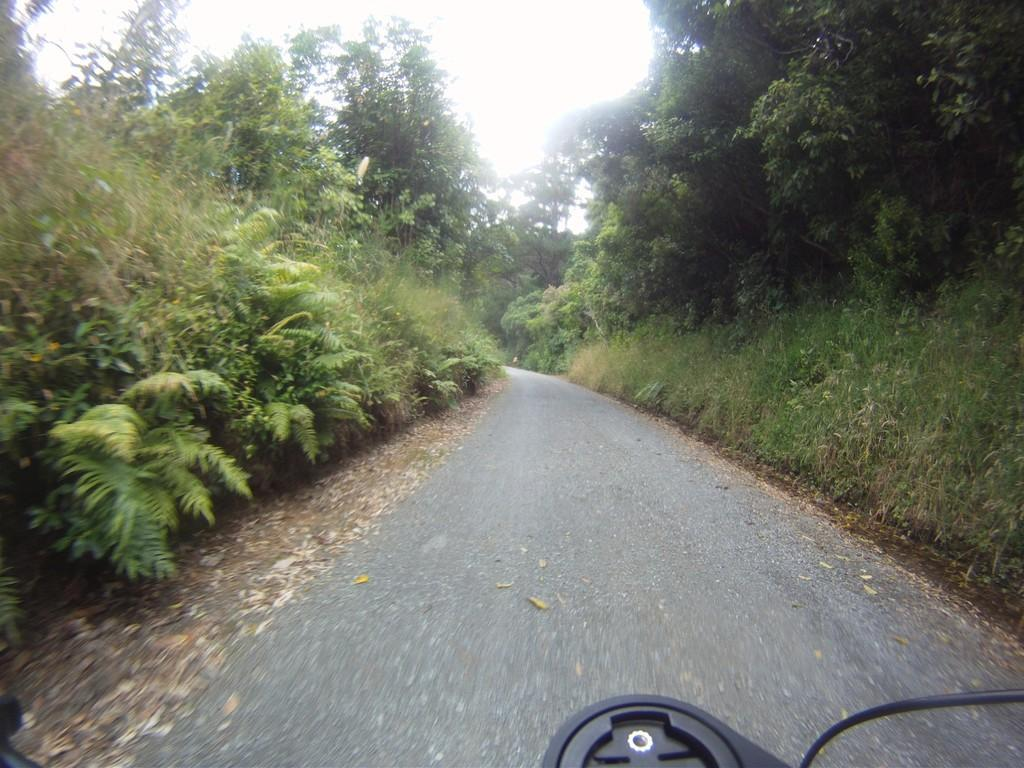What is located at the bottom of the image? There is a vehicle and a walkway at the bottom of the image. What type of vegetation can be seen on the right side of the image? There are plants and trees on the right side of the image. What type of vegetation can be seen on the left side of the image? There are plants and trees on the left side of the image. What is visible at the top of the image? The sky is visible at the top of the image. What type of wine is being served on the walkway in the image? There is no wine present in the image; it features a vehicle, walkway, plants, trees, and sky. What type of vacation destination is depicted in the image? The image does not depict a specific vacation destination; it shows a vehicle, walkway, plants, trees, and sky. 